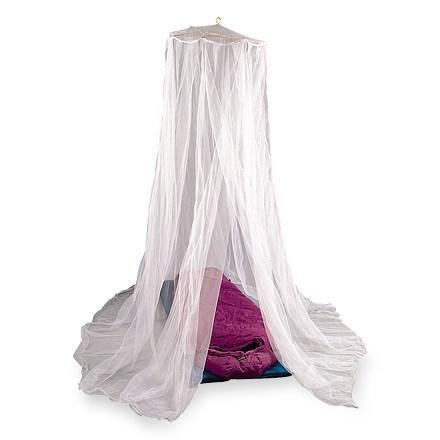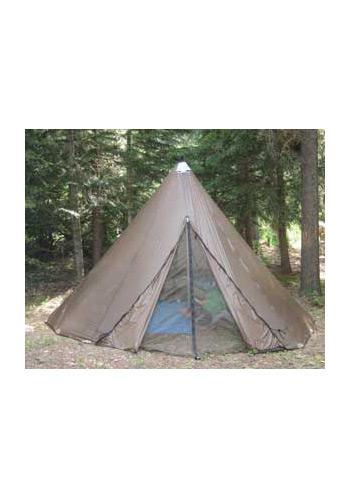The first image is the image on the left, the second image is the image on the right. Assess this claim about the two images: "There are two canopies with at least one mostly square one.". Correct or not? Answer yes or no. No. The first image is the image on the left, the second image is the image on the right. For the images displayed, is the sentence "The tents are both empty." factually correct? Answer yes or no. No. 